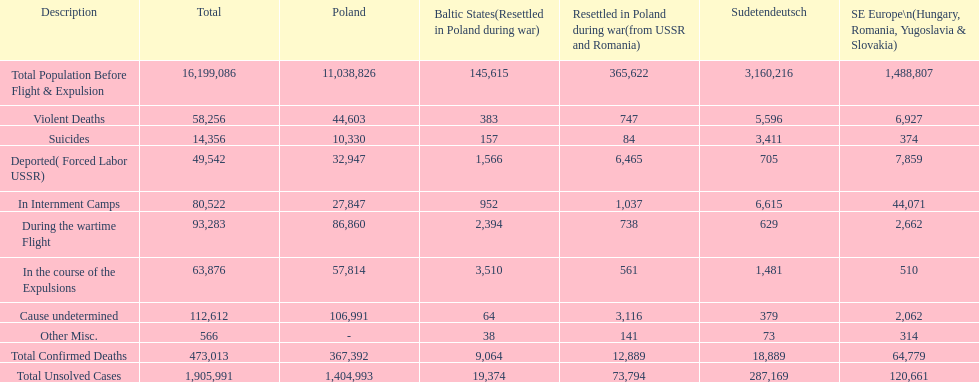Did any location have no violent deaths? No. Give me the full table as a dictionary. {'header': ['Description', 'Total', 'Poland', 'Baltic States(Resettled in Poland during war)', 'Resettled in Poland during war(from USSR and Romania)', 'Sudetendeutsch', 'SE Europe\\n(Hungary, Romania, Yugoslavia & Slovakia)'], 'rows': [['Total Population Before Flight & Expulsion', '16,199,086', '11,038,826', '145,615', '365,622', '3,160,216', '1,488,807'], ['Violent Deaths', '58,256', '44,603', '383', '747', '5,596', '6,927'], ['Suicides', '14,356', '10,330', '157', '84', '3,411', '374'], ['Deported( Forced Labor USSR)', '49,542', '32,947', '1,566', '6,465', '705', '7,859'], ['In Internment Camps', '80,522', '27,847', '952', '1,037', '6,615', '44,071'], ['During the wartime Flight', '93,283', '86,860', '2,394', '738', '629', '2,662'], ['In the course of the Expulsions', '63,876', '57,814', '3,510', '561', '1,481', '510'], ['Cause undetermined', '112,612', '106,991', '64', '3,116', '379', '2,062'], ['Other Misc.', '566', '-', '38', '141', '73', '314'], ['Total Confirmed Deaths', '473,013', '367,392', '9,064', '12,889', '18,889', '64,779'], ['Total Unsolved Cases', '1,905,991', '1,404,993', '19,374', '73,794', '287,169', '120,661']]} 